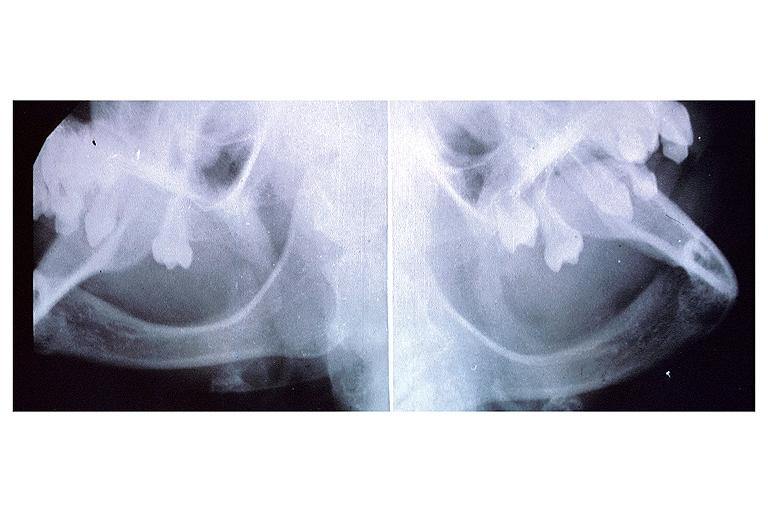what does this image show?
Answer the question using a single word or phrase. Anhidrotic ectodermal dysplasia 